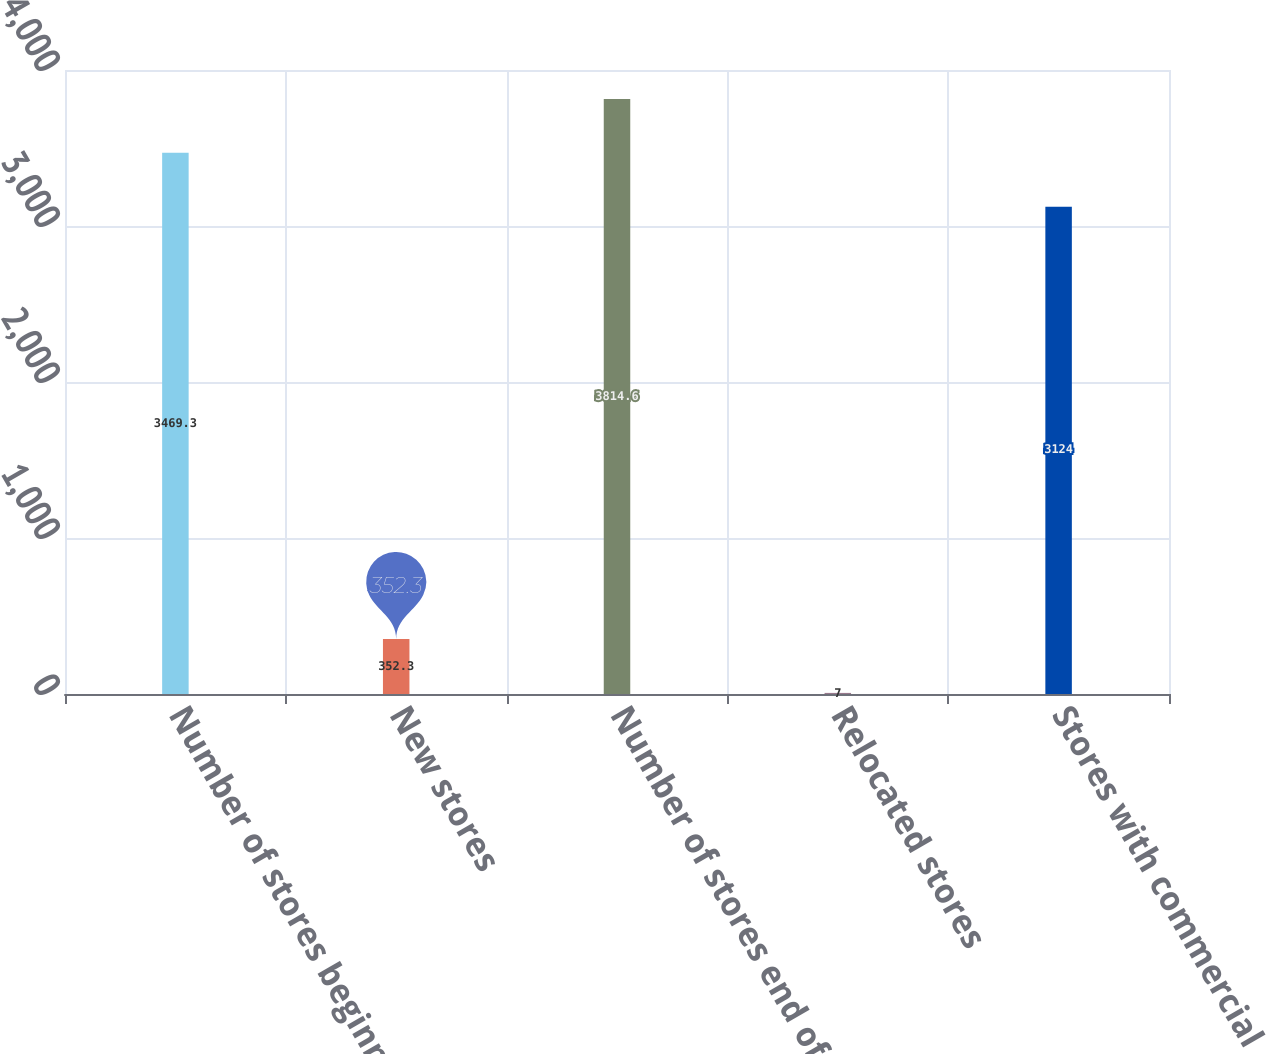Convert chart. <chart><loc_0><loc_0><loc_500><loc_500><bar_chart><fcel>Number of stores beginning of<fcel>New stores<fcel>Number of stores end of year<fcel>Relocated stores<fcel>Stores with commercial<nl><fcel>3469.3<fcel>352.3<fcel>3814.6<fcel>7<fcel>3124<nl></chart> 